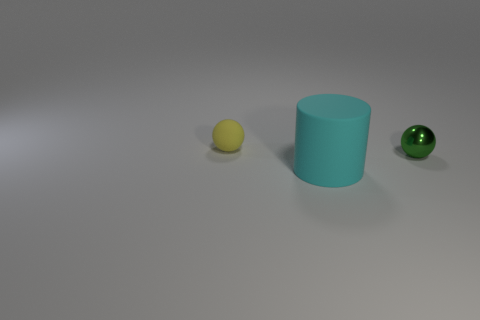Add 3 yellow rubber balls. How many objects exist? 6 Subtract all balls. How many objects are left? 1 Subtract all tiny yellow matte things. Subtract all green metal spheres. How many objects are left? 1 Add 1 large cyan rubber cylinders. How many large cyan rubber cylinders are left? 2 Add 3 matte spheres. How many matte spheres exist? 4 Subtract 1 cyan cylinders. How many objects are left? 2 